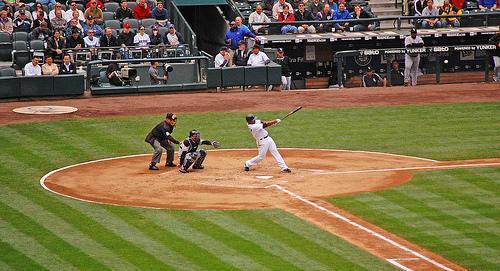How many people are playing baseball in this photo?
Give a very brief answer. 3. How many people are swinging a baseball bat?
Give a very brief answer. 1. 